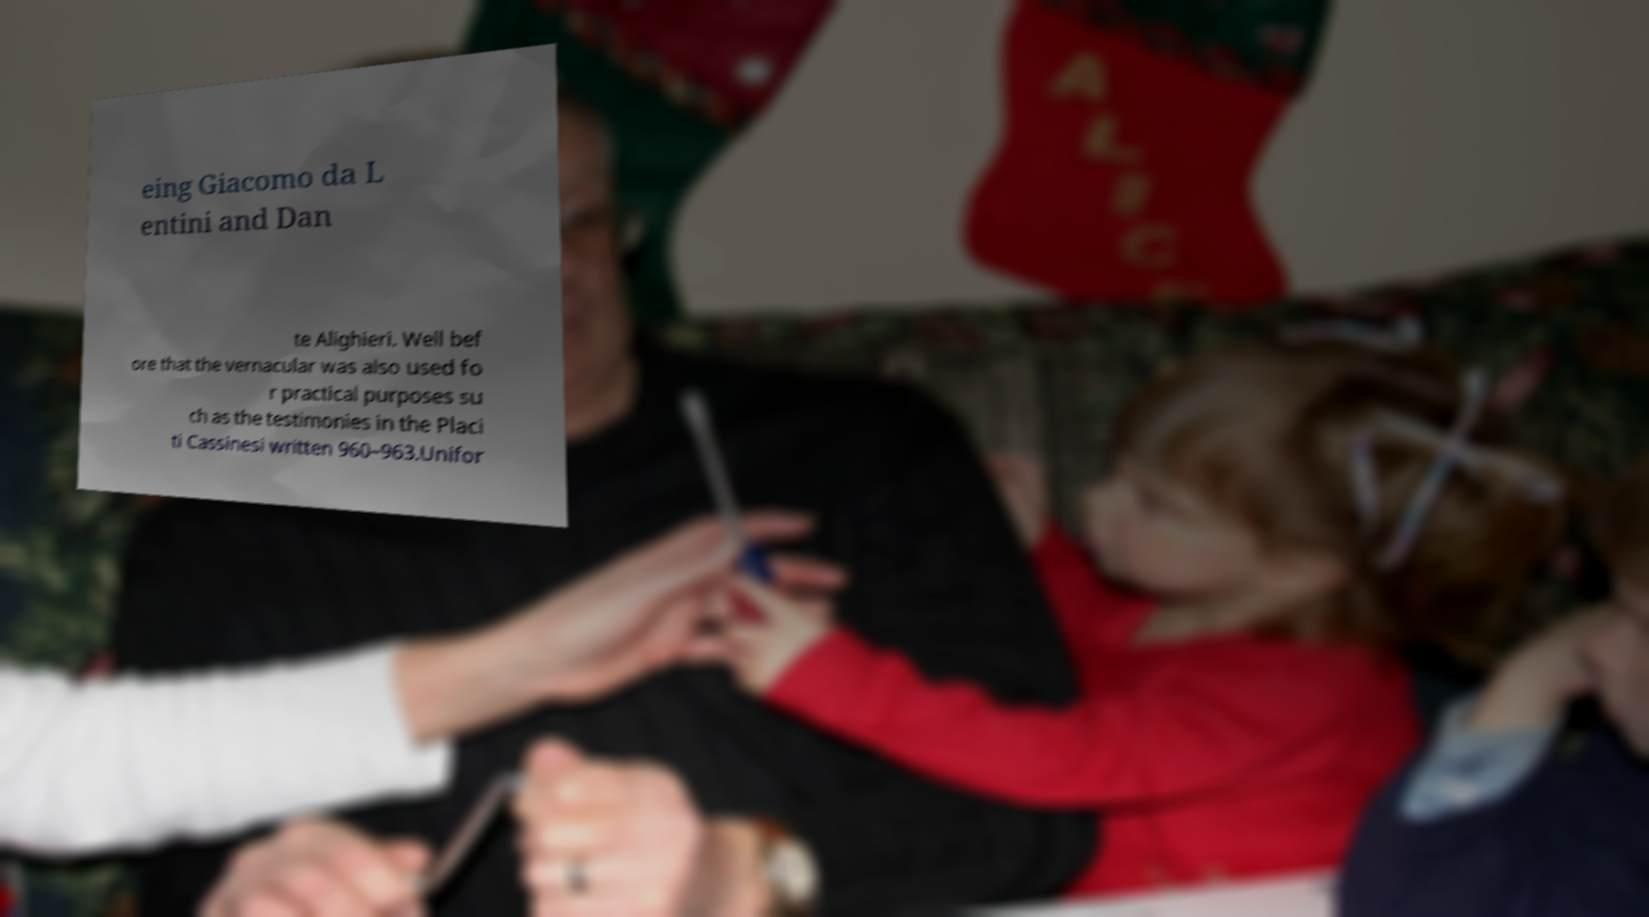What messages or text are displayed in this image? I need them in a readable, typed format. eing Giacomo da L entini and Dan te Alighieri. Well bef ore that the vernacular was also used fo r practical purposes su ch as the testimonies in the Placi ti Cassinesi written 960–963.Unifor 